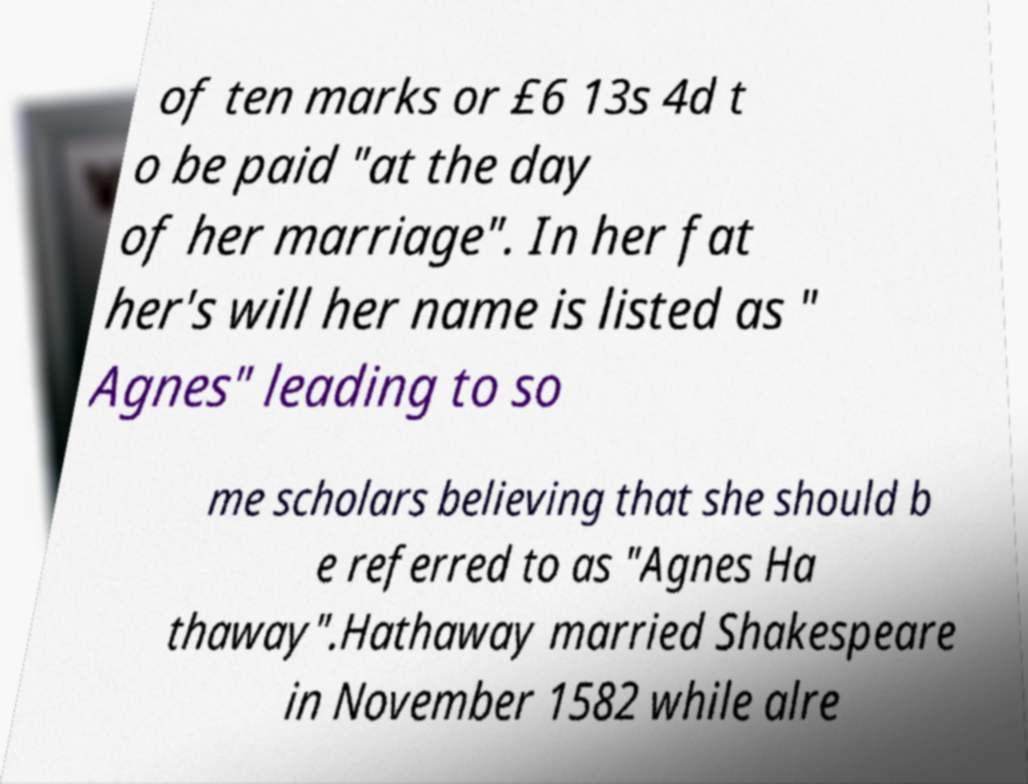For documentation purposes, I need the text within this image transcribed. Could you provide that? of ten marks or £6 13s 4d t o be paid "at the day of her marriage". In her fat her's will her name is listed as " Agnes" leading to so me scholars believing that she should b e referred to as "Agnes Ha thaway".Hathaway married Shakespeare in November 1582 while alre 